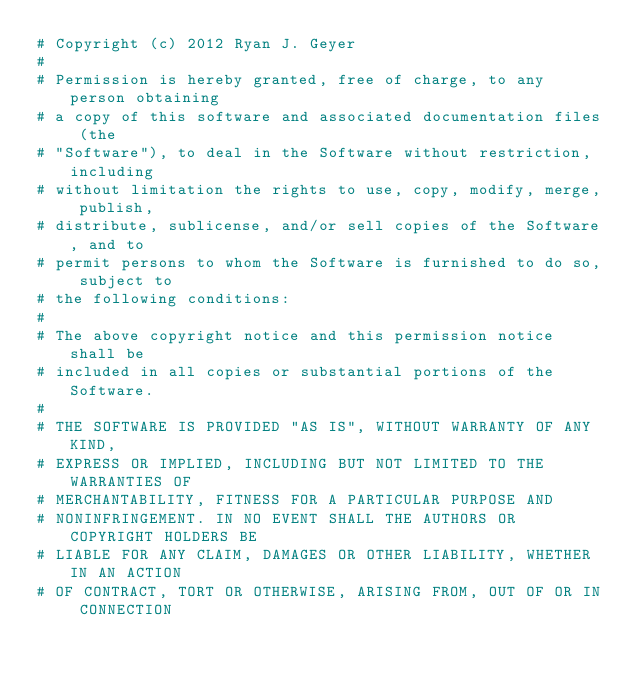Convert code to text. <code><loc_0><loc_0><loc_500><loc_500><_Ruby_># Copyright (c) 2012 Ryan J. Geyer
#
# Permission is hereby granted, free of charge, to any person obtaining
# a copy of this software and associated documentation files (the
# "Software"), to deal in the Software without restriction, including
# without limitation the rights to use, copy, modify, merge, publish,
# distribute, sublicense, and/or sell copies of the Software, and to
# permit persons to whom the Software is furnished to do so, subject to
# the following conditions:
#
# The above copyright notice and this permission notice shall be
# included in all copies or substantial portions of the Software.
#
# THE SOFTWARE IS PROVIDED "AS IS", WITHOUT WARRANTY OF ANY KIND,
# EXPRESS OR IMPLIED, INCLUDING BUT NOT LIMITED TO THE WARRANTIES OF
# MERCHANTABILITY, FITNESS FOR A PARTICULAR PURPOSE AND
# NONINFRINGEMENT. IN NO EVENT SHALL THE AUTHORS OR COPYRIGHT HOLDERS BE
# LIABLE FOR ANY CLAIM, DAMAGES OR OTHER LIABILITY, WHETHER IN AN ACTION
# OF CONTRACT, TORT OR OTHERWISE, ARISING FROM, OUT OF OR IN CONNECTION</code> 